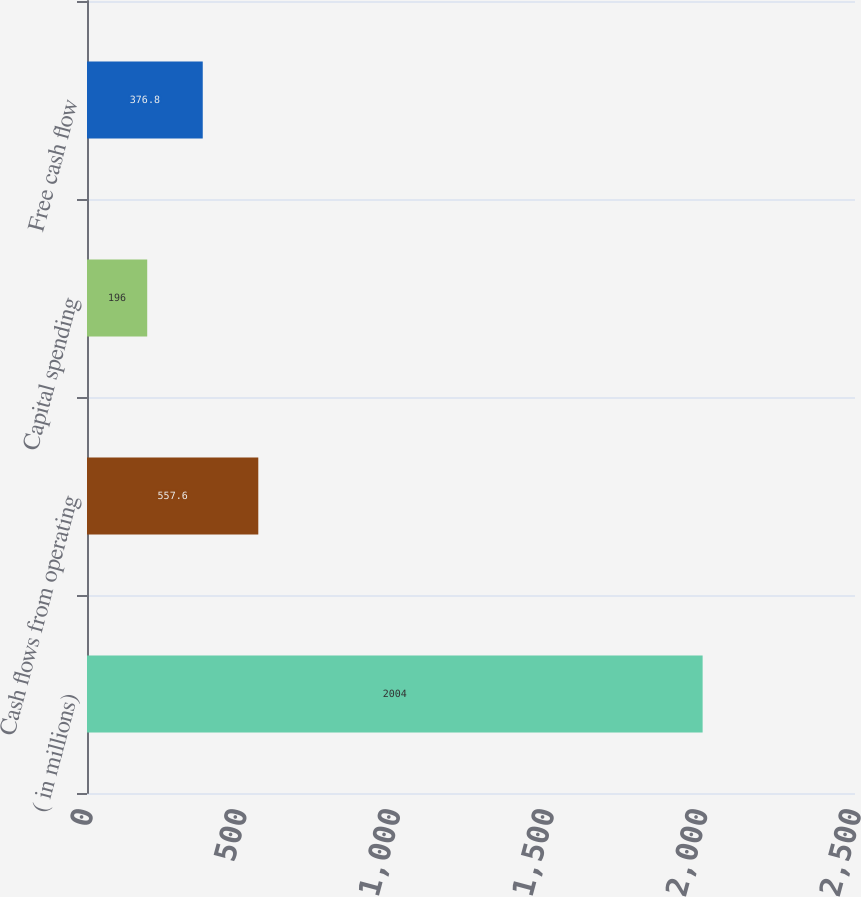Convert chart. <chart><loc_0><loc_0><loc_500><loc_500><bar_chart><fcel>( in millions)<fcel>Cash flows from operating<fcel>Capital spending<fcel>Free cash flow<nl><fcel>2004<fcel>557.6<fcel>196<fcel>376.8<nl></chart> 